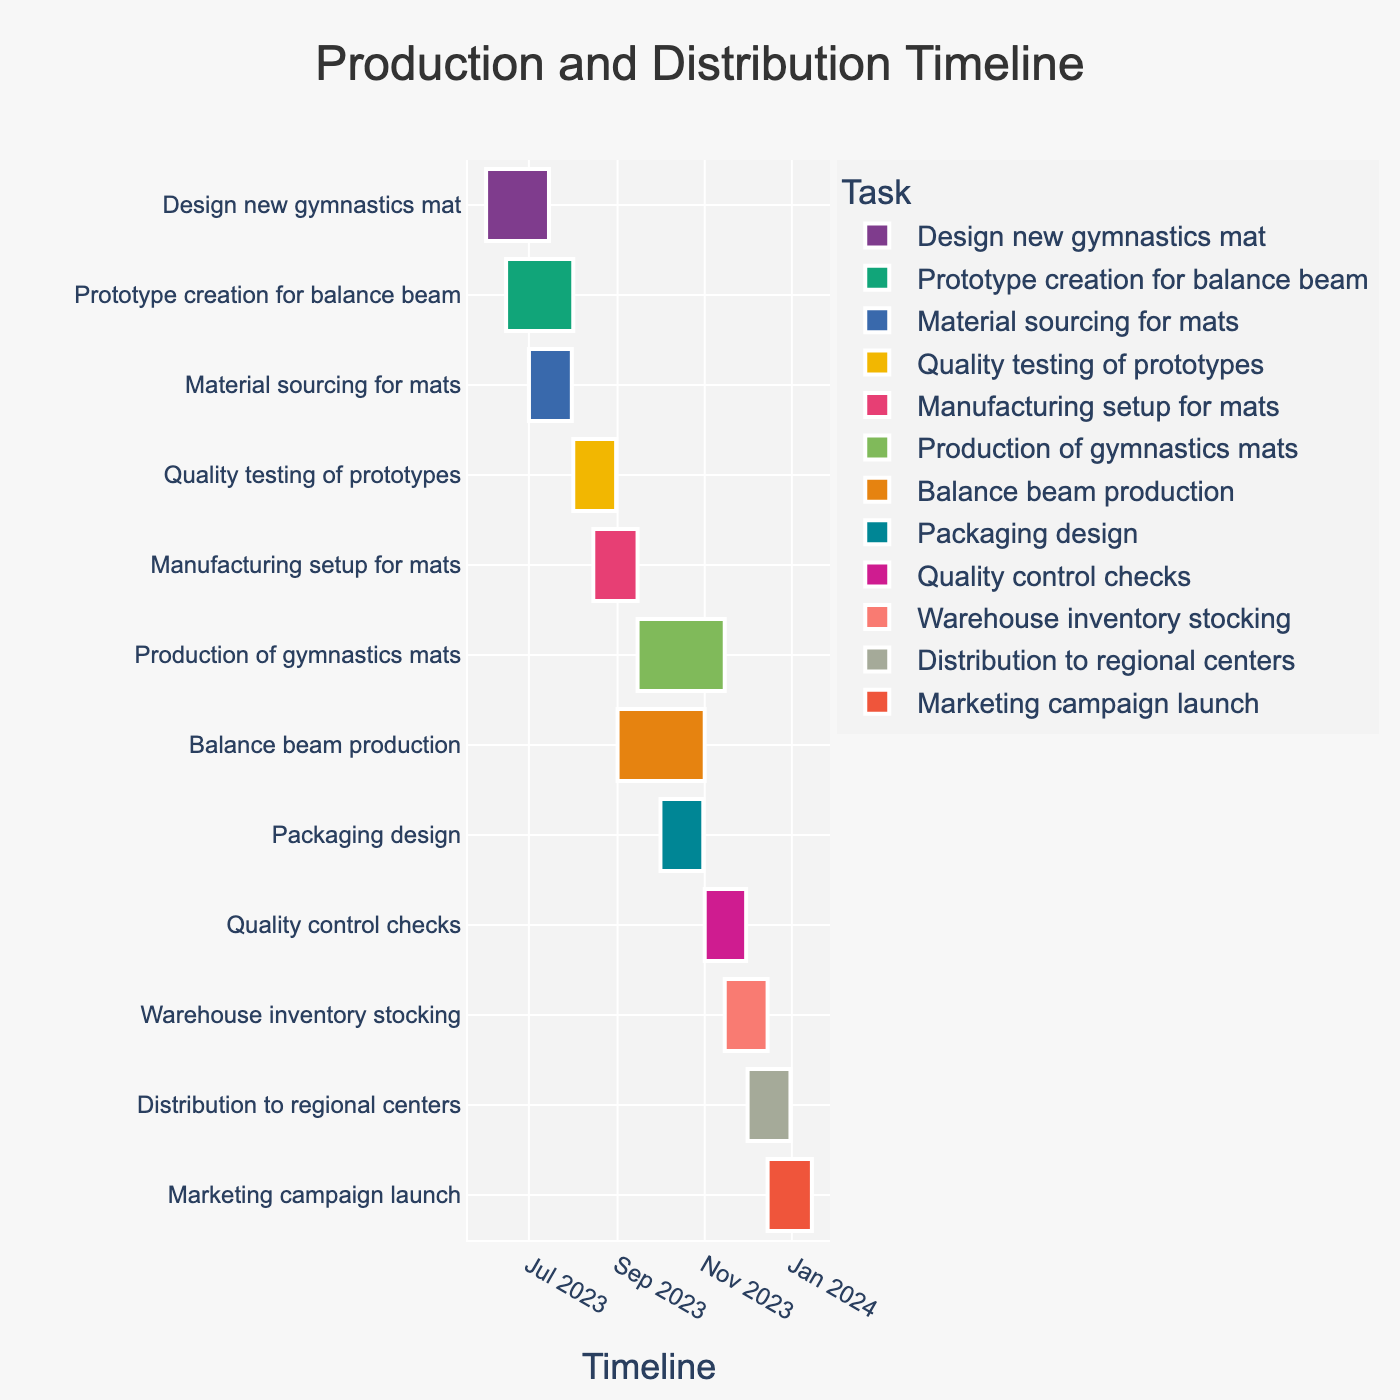What's the title of the Gantt chart? The title of a chart is typically located at the top center, providing a summary of what the chart represents.
Answer: Production and Distribution Timeline Which task spans the earliest start date? To determine which task starts the earliest, look for the starting point that is closest to the left side of the timeline.
Answer: Design new gymnastics mat How long is the "Quality control checks" task in terms of duration? Find the start and end dates for "Quality control checks" and calculate the duration between these two dates. From November 1, 2023, to November 30, 2023, is 30 days.
Answer: 30 days Which task finishes the latest in 2023? Identify the task that ends closest to the end of 2023 by finding the task bar ending closest to December 31, 2023.
Answer: Distribution to regional centers What is the overlap period between "Quality testing of prototypes" and "Manufacturing setup for mats"? To find the overlap, compare the dates: "Quality testing of prototypes" runs from August 1 to August 31, 2023, and "Manufacturing setup for mats" is from August 15 to September 15, 2023. There is an overlap from August 15 to August 31, which is 16 days.
Answer: 16 days Which tasks are scheduled in December 2023? Look at the timeline for tasks that have bars extending into December 2023. These tasks are "Warehouse inventory stocking" and "Distribution to regional centers".
Answer: Warehouse inventory stocking, Distribution to regional centers Compare the duration of "Production of gymnastics mats" and "Balance beam production". Which one lasts longer? Calculate the duration of each task. "Production of gymnastics mats" is from September 15 to November 15, 2023, which is 61 days. "Balance beam production" is from September 1 to November 1, 2023, which is 62 days. Comparing these, "Balance beam production" is 1 day longer.
Answer: Balance beam production What is the total duration from the start of the first task to the end of the last task? Identify the start date of the first task and the end date of the last task, then calculate the total duration. The timeline spans from June 1, 2023, to January 15, 2024, equating to approximately 229 days.
Answer: 229 days Which task is directly before "Marketing campaign launch"? Look at the task that ends just before "Marketing campaign launch" begins on December 15, 2023. The task "Distribution to regional centers" ends on December 31, 2023, so the one completing directly before is "Warehouse inventory stocking", ending on December 15, 2023.
Answer: Distribution to regional centers What are the tasks that have a planned duration longer than two months? Look at the start and end dates for each task and measure if they exceed two months (roughly 60 days). The tasks exceeding this are "Production of gymnastics mats" (61 days) and "Balance beam production" (62 days).
Answer: Production of gymnastics mats, Balance beam production 